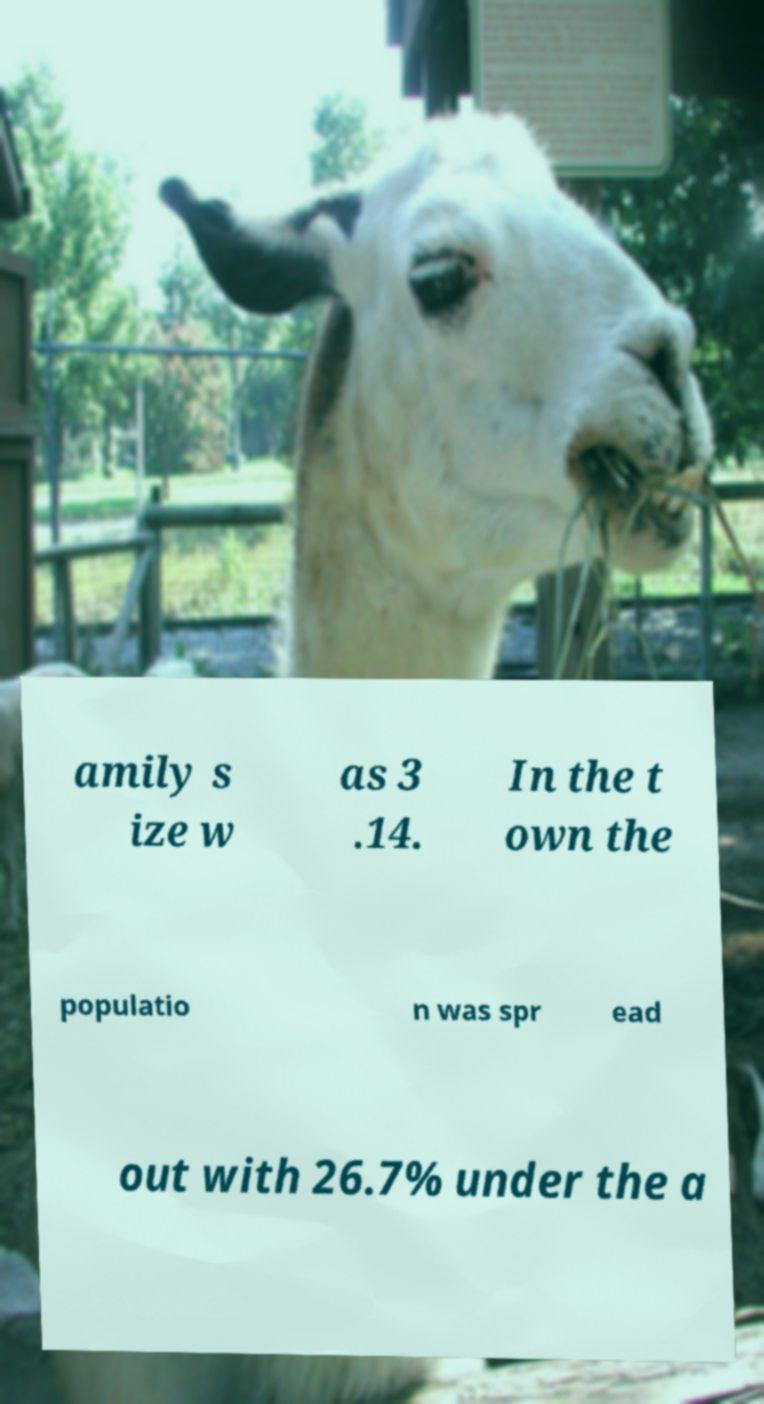Can you read and provide the text displayed in the image?This photo seems to have some interesting text. Can you extract and type it out for me? amily s ize w as 3 .14. In the t own the populatio n was spr ead out with 26.7% under the a 